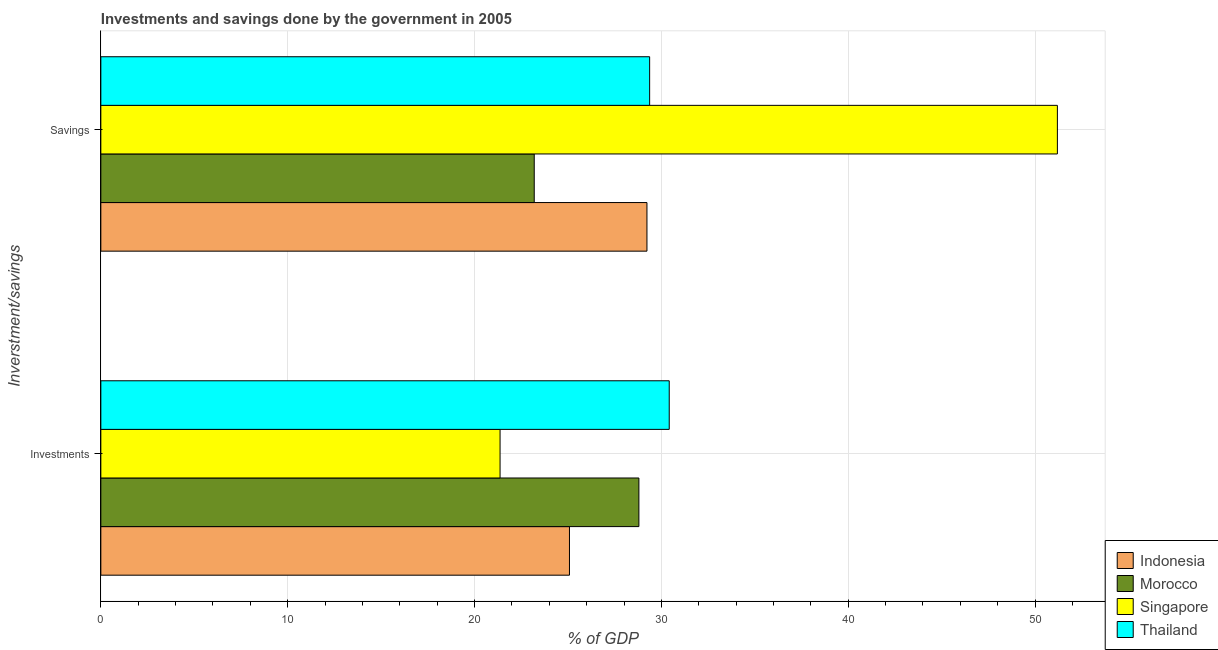How many different coloured bars are there?
Give a very brief answer. 4. How many groups of bars are there?
Give a very brief answer. 2. Are the number of bars per tick equal to the number of legend labels?
Your response must be concise. Yes. Are the number of bars on each tick of the Y-axis equal?
Your answer should be very brief. Yes. What is the label of the 1st group of bars from the top?
Provide a succinct answer. Savings. What is the savings of government in Morocco?
Your answer should be compact. 23.2. Across all countries, what is the maximum savings of government?
Your response must be concise. 51.2. Across all countries, what is the minimum investments of government?
Your response must be concise. 21.37. In which country was the investments of government maximum?
Give a very brief answer. Thailand. In which country was the investments of government minimum?
Your answer should be compact. Singapore. What is the total savings of government in the graph?
Provide a succinct answer. 132.99. What is the difference between the savings of government in Indonesia and that in Thailand?
Provide a succinct answer. -0.14. What is the difference between the savings of government in Singapore and the investments of government in Morocco?
Your answer should be compact. 22.4. What is the average savings of government per country?
Provide a short and direct response. 33.25. What is the difference between the investments of government and savings of government in Indonesia?
Your response must be concise. -4.15. In how many countries, is the savings of government greater than 2 %?
Your answer should be compact. 4. What is the ratio of the investments of government in Singapore to that in Thailand?
Offer a very short reply. 0.7. In how many countries, is the savings of government greater than the average savings of government taken over all countries?
Your answer should be very brief. 1. What does the 1st bar from the top in Savings represents?
Keep it short and to the point. Thailand. What does the 2nd bar from the bottom in Savings represents?
Your response must be concise. Morocco. How many bars are there?
Offer a very short reply. 8. Are all the bars in the graph horizontal?
Keep it short and to the point. Yes. Are the values on the major ticks of X-axis written in scientific E-notation?
Give a very brief answer. No. Does the graph contain any zero values?
Give a very brief answer. No. How many legend labels are there?
Offer a very short reply. 4. What is the title of the graph?
Offer a terse response. Investments and savings done by the government in 2005. Does "Lesotho" appear as one of the legend labels in the graph?
Your response must be concise. No. What is the label or title of the X-axis?
Your answer should be compact. % of GDP. What is the label or title of the Y-axis?
Keep it short and to the point. Inverstment/savings. What is the % of GDP of Indonesia in Investments?
Your response must be concise. 25.08. What is the % of GDP of Morocco in Investments?
Give a very brief answer. 28.8. What is the % of GDP in Singapore in Investments?
Keep it short and to the point. 21.37. What is the % of GDP in Thailand in Investments?
Provide a succinct answer. 30.42. What is the % of GDP of Indonesia in Savings?
Keep it short and to the point. 29.23. What is the % of GDP in Morocco in Savings?
Ensure brevity in your answer.  23.2. What is the % of GDP of Singapore in Savings?
Your answer should be compact. 51.2. What is the % of GDP in Thailand in Savings?
Your answer should be very brief. 29.37. Across all Inverstment/savings, what is the maximum % of GDP of Indonesia?
Your answer should be very brief. 29.23. Across all Inverstment/savings, what is the maximum % of GDP of Morocco?
Ensure brevity in your answer.  28.8. Across all Inverstment/savings, what is the maximum % of GDP of Singapore?
Give a very brief answer. 51.2. Across all Inverstment/savings, what is the maximum % of GDP of Thailand?
Provide a succinct answer. 30.42. Across all Inverstment/savings, what is the minimum % of GDP of Indonesia?
Offer a very short reply. 25.08. Across all Inverstment/savings, what is the minimum % of GDP of Morocco?
Ensure brevity in your answer.  23.2. Across all Inverstment/savings, what is the minimum % of GDP in Singapore?
Offer a very short reply. 21.37. Across all Inverstment/savings, what is the minimum % of GDP in Thailand?
Your answer should be compact. 29.37. What is the total % of GDP of Indonesia in the graph?
Provide a short and direct response. 54.31. What is the total % of GDP in Morocco in the graph?
Make the answer very short. 51.99. What is the total % of GDP of Singapore in the graph?
Offer a very short reply. 72.56. What is the total % of GDP of Thailand in the graph?
Provide a succinct answer. 59.79. What is the difference between the % of GDP in Indonesia in Investments and that in Savings?
Offer a very short reply. -4.15. What is the difference between the % of GDP in Morocco in Investments and that in Savings?
Provide a short and direct response. 5.6. What is the difference between the % of GDP in Singapore in Investments and that in Savings?
Offer a terse response. -29.83. What is the difference between the % of GDP of Thailand in Investments and that in Savings?
Your answer should be compact. 1.05. What is the difference between the % of GDP of Indonesia in Investments and the % of GDP of Morocco in Savings?
Give a very brief answer. 1.89. What is the difference between the % of GDP in Indonesia in Investments and the % of GDP in Singapore in Savings?
Make the answer very short. -26.11. What is the difference between the % of GDP of Indonesia in Investments and the % of GDP of Thailand in Savings?
Offer a terse response. -4.29. What is the difference between the % of GDP in Morocco in Investments and the % of GDP in Singapore in Savings?
Offer a very short reply. -22.4. What is the difference between the % of GDP in Morocco in Investments and the % of GDP in Thailand in Savings?
Keep it short and to the point. -0.58. What is the difference between the % of GDP in Singapore in Investments and the % of GDP in Thailand in Savings?
Your answer should be compact. -8.01. What is the average % of GDP of Indonesia per Inverstment/savings?
Your answer should be very brief. 27.15. What is the average % of GDP of Morocco per Inverstment/savings?
Provide a short and direct response. 26. What is the average % of GDP of Singapore per Inverstment/savings?
Ensure brevity in your answer.  36.28. What is the average % of GDP of Thailand per Inverstment/savings?
Offer a terse response. 29.9. What is the difference between the % of GDP of Indonesia and % of GDP of Morocco in Investments?
Make the answer very short. -3.72. What is the difference between the % of GDP in Indonesia and % of GDP in Singapore in Investments?
Your response must be concise. 3.71. What is the difference between the % of GDP in Indonesia and % of GDP in Thailand in Investments?
Make the answer very short. -5.34. What is the difference between the % of GDP of Morocco and % of GDP of Singapore in Investments?
Your answer should be very brief. 7.43. What is the difference between the % of GDP in Morocco and % of GDP in Thailand in Investments?
Provide a succinct answer. -1.62. What is the difference between the % of GDP in Singapore and % of GDP in Thailand in Investments?
Make the answer very short. -9.05. What is the difference between the % of GDP of Indonesia and % of GDP of Morocco in Savings?
Offer a very short reply. 6.03. What is the difference between the % of GDP in Indonesia and % of GDP in Singapore in Savings?
Ensure brevity in your answer.  -21.97. What is the difference between the % of GDP of Indonesia and % of GDP of Thailand in Savings?
Offer a very short reply. -0.14. What is the difference between the % of GDP in Morocco and % of GDP in Singapore in Savings?
Your answer should be compact. -28. What is the difference between the % of GDP of Morocco and % of GDP of Thailand in Savings?
Offer a very short reply. -6.18. What is the difference between the % of GDP of Singapore and % of GDP of Thailand in Savings?
Keep it short and to the point. 21.82. What is the ratio of the % of GDP in Indonesia in Investments to that in Savings?
Provide a short and direct response. 0.86. What is the ratio of the % of GDP of Morocco in Investments to that in Savings?
Offer a terse response. 1.24. What is the ratio of the % of GDP of Singapore in Investments to that in Savings?
Ensure brevity in your answer.  0.42. What is the ratio of the % of GDP in Thailand in Investments to that in Savings?
Your answer should be very brief. 1.04. What is the difference between the highest and the second highest % of GDP in Indonesia?
Give a very brief answer. 4.15. What is the difference between the highest and the second highest % of GDP of Morocco?
Provide a short and direct response. 5.6. What is the difference between the highest and the second highest % of GDP of Singapore?
Make the answer very short. 29.83. What is the difference between the highest and the second highest % of GDP of Thailand?
Offer a very short reply. 1.05. What is the difference between the highest and the lowest % of GDP of Indonesia?
Offer a terse response. 4.15. What is the difference between the highest and the lowest % of GDP of Morocco?
Keep it short and to the point. 5.6. What is the difference between the highest and the lowest % of GDP of Singapore?
Offer a terse response. 29.83. What is the difference between the highest and the lowest % of GDP in Thailand?
Offer a very short reply. 1.05. 